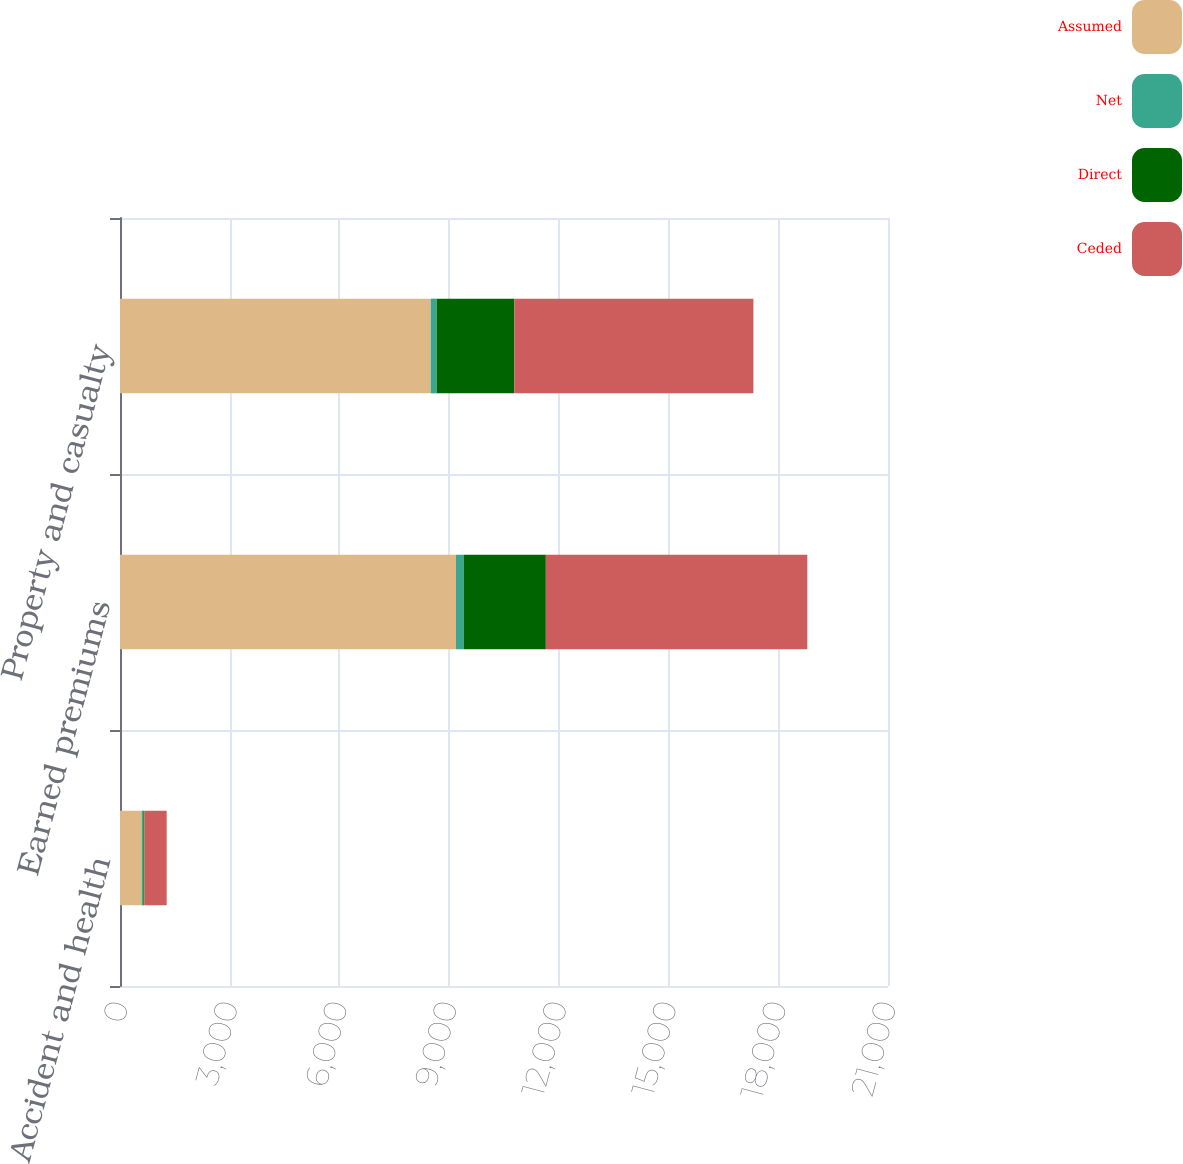<chart> <loc_0><loc_0><loc_500><loc_500><stacked_bar_chart><ecel><fcel>Accident and health<fcel>Earned premiums<fcel>Property and casualty<nl><fcel>Assumed<fcel>592<fcel>9187<fcel>8496<nl><fcel>Net<fcel>46<fcel>210<fcel>164<nl><fcel>Direct<fcel>28<fcel>2247<fcel>2121<nl><fcel>Ceded<fcel>610<fcel>7150<fcel>6539<nl></chart> 